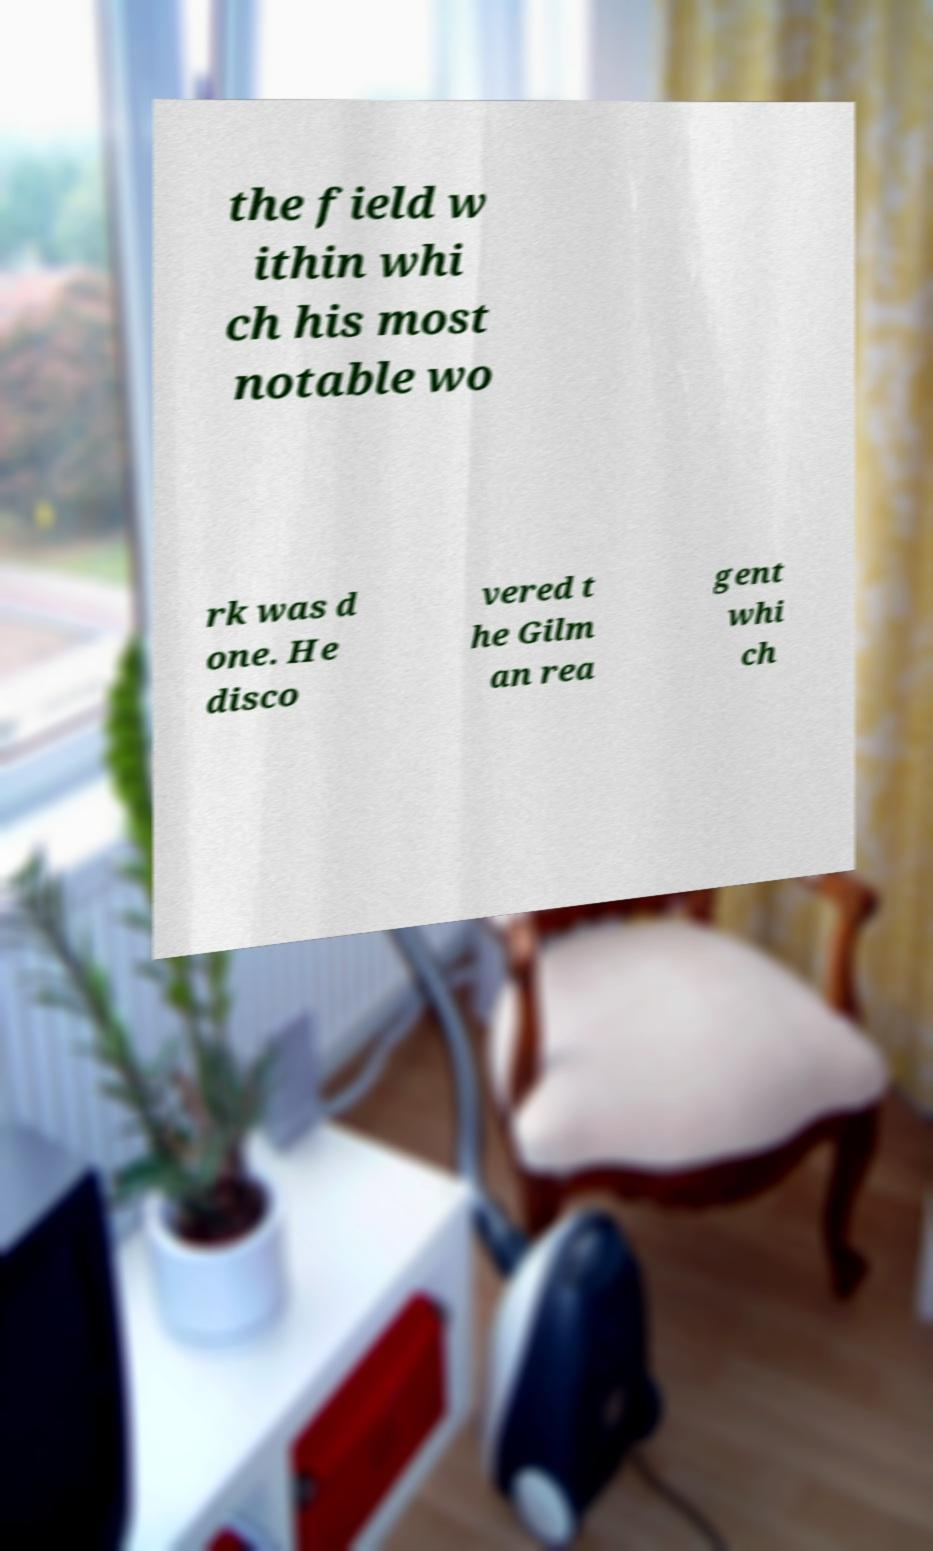Can you accurately transcribe the text from the provided image for me? the field w ithin whi ch his most notable wo rk was d one. He disco vered t he Gilm an rea gent whi ch 